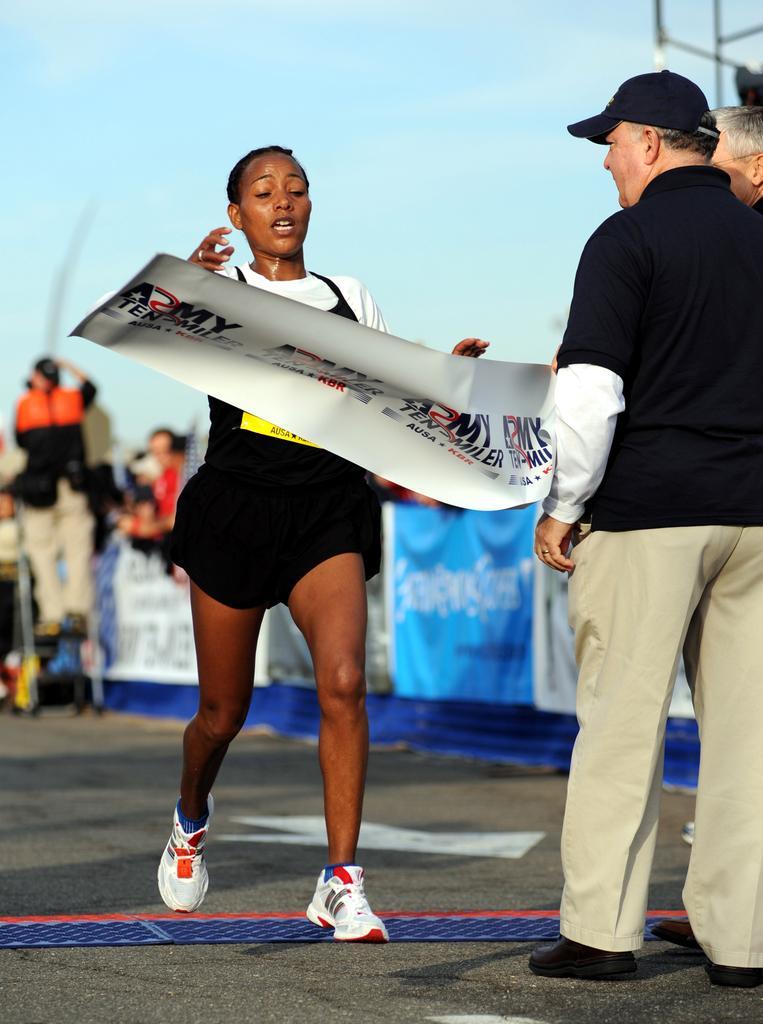How would you summarize this image in a sentence or two? In this image there is a woman running on the road. Before her there are two persons standing on the road. They are holding a banner. Person wearing a black top is having cap. Left side there are few persons. Top of the image there is sky. 